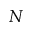<formula> <loc_0><loc_0><loc_500><loc_500>N</formula> 